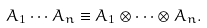<formula> <loc_0><loc_0><loc_500><loc_500>A _ { 1 } \cdots A _ { n } \equiv A _ { 1 } \otimes \cdots \otimes A _ { n } .</formula> 